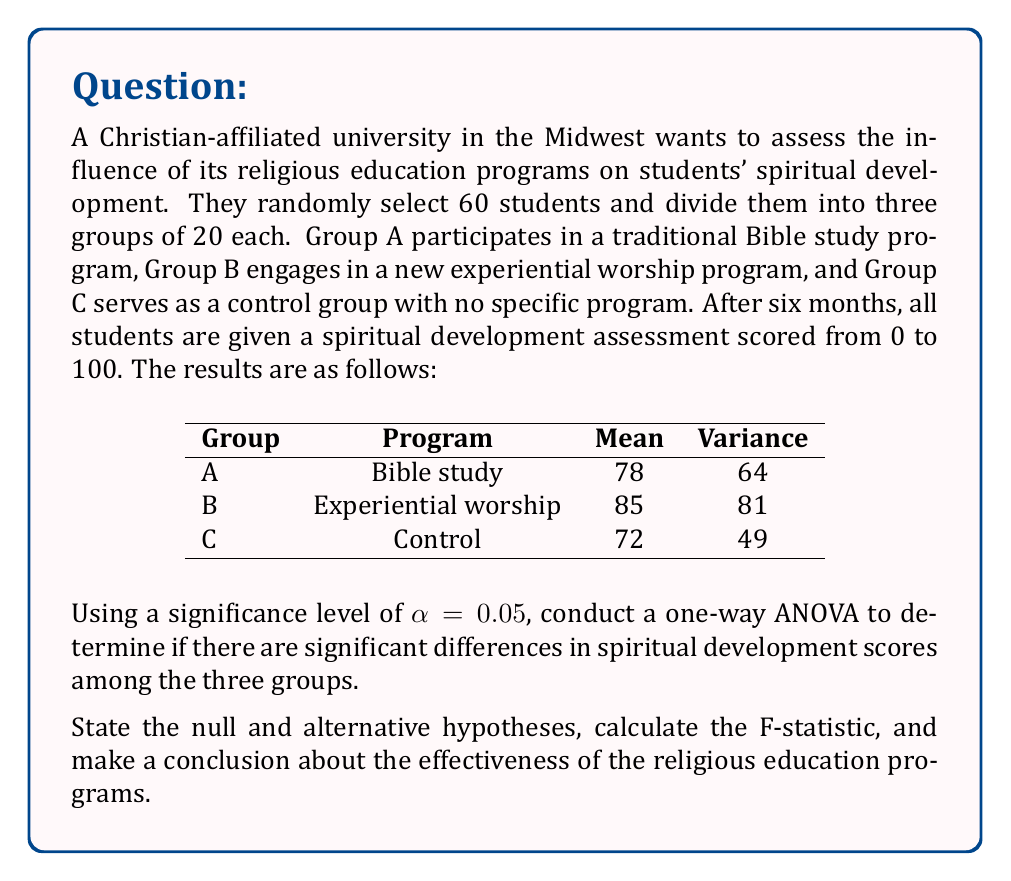Provide a solution to this math problem. To solve this problem, we'll follow these steps:

1. State the null and alternative hypotheses
2. Calculate the sum of squares between groups (SSB)
3. Calculate the sum of squares within groups (SSW)
4. Calculate the degrees of freedom
5. Compute the mean square between groups (MSB) and mean square within groups (MSW)
6. Calculate the F-statistic
7. Find the critical F-value
8. Make a conclusion

Step 1: Hypotheses
$H_0: \mu_A = \mu_B = \mu_C$ (no difference in means)
$H_a:$ At least one mean is different

Step 2: Calculate SSB
$$SSB = \sum_{i=1}^k n_i(\bar{X}_i - \bar{X})^2$$
where $k$ is the number of groups, $n_i$ is the sample size of each group, $\bar{X}_i$ is the mean of each group, and $\bar{X}$ is the grand mean.

Grand mean: $\bar{X} = \frac{78 + 85 + 72}{3} = 78.33$

$$SSB = 20(78 - 78.33)^2 + 20(85 - 78.33)^2 + 20(72 - 78.33)^2 = 1706.67$$

Step 3: Calculate SSW
$$SSW = \sum_{i=1}^k (n_i - 1)s_i^2$$
where $s_i^2$ is the variance of each group.

$$SSW = 19(64) + 19(81) + 19(49) = 3686$$

Step 4: Degrees of freedom
$df_{between} = k - 1 = 3 - 1 = 2$
$df_{within} = N - k = 60 - 3 = 57$
where $N$ is the total sample size.

Step 5: Compute MSB and MSW
$$MSB = \frac{SSB}{df_{between}} = \frac{1706.67}{2} = 853.33$$
$$MSW = \frac{SSW}{df_{within}} = \frac{3686}{57} = 64.67$$

Step 6: Calculate F-statistic
$$F = \frac{MSB}{MSW} = \frac{853.33}{64.67} = 13.19$$

Step 7: Find critical F-value
For $\alpha = 0.05$, $df_{between} = 2$, and $df_{within} = 57$, the critical F-value is approximately 3.16.

Step 8: Make a conclusion
Since the calculated F-statistic (13.19) is greater than the critical F-value (3.16), we reject the null hypothesis.
Answer: Reject the null hypothesis. There is significant evidence to suggest that at least one of the religious education programs has a different effect on students' spiritual development scores (F(2, 57) = 13.19, p < 0.05). This indicates that the religious education programs have a significant influence on students' spiritual development in this faith-based institution. 